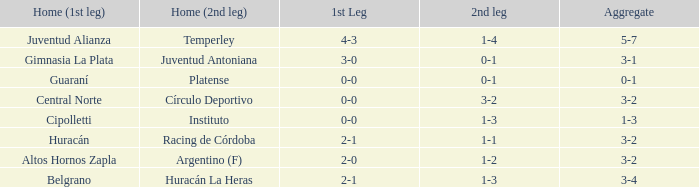What was the aggregate score that had a 1-2 second leg score? 3-2. 